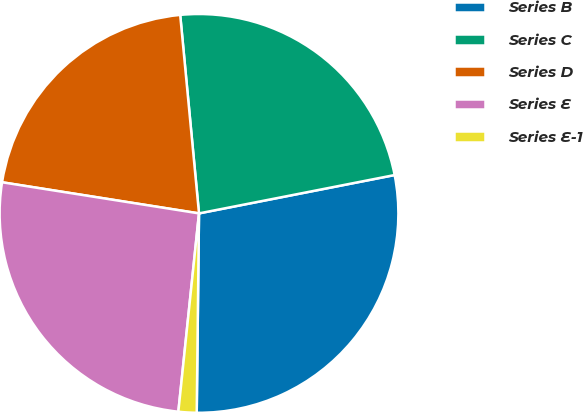<chart> <loc_0><loc_0><loc_500><loc_500><pie_chart><fcel>Series B<fcel>Series C<fcel>Series D<fcel>Series E<fcel>Series E-1<nl><fcel>28.26%<fcel>23.42%<fcel>21.0%<fcel>25.84%<fcel>1.47%<nl></chart> 